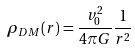<formula> <loc_0><loc_0><loc_500><loc_500>\rho _ { D M } ( r ) = \frac { v _ { 0 } ^ { 2 } } { 4 \pi G } \frac { 1 } { r ^ { 2 } }</formula> 